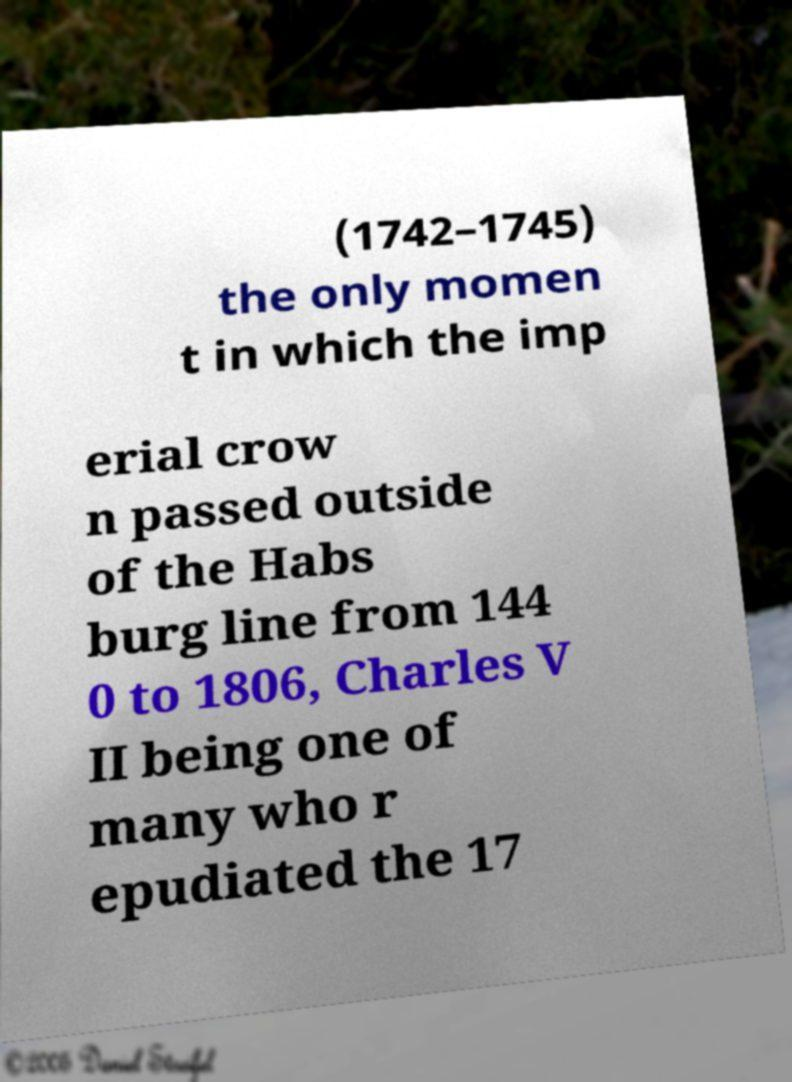There's text embedded in this image that I need extracted. Can you transcribe it verbatim? (1742–1745) the only momen t in which the imp erial crow n passed outside of the Habs burg line from 144 0 to 1806, Charles V II being one of many who r epudiated the 17 